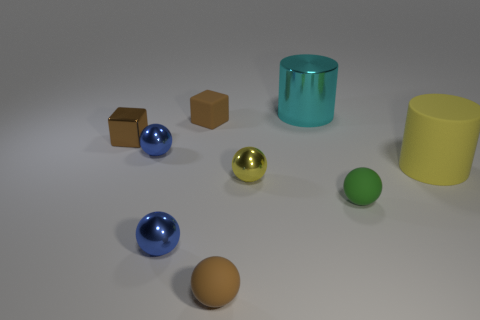Subtract all brown spheres. How many spheres are left? 4 Subtract all brown spheres. How many spheres are left? 4 Subtract all purple spheres. Subtract all cyan cylinders. How many spheres are left? 5 Subtract all cylinders. How many objects are left? 7 Subtract 0 green cylinders. How many objects are left? 9 Subtract all green rubber things. Subtract all large cyan metallic objects. How many objects are left? 7 Add 5 tiny blocks. How many tiny blocks are left? 7 Add 5 small brown rubber balls. How many small brown rubber balls exist? 6 